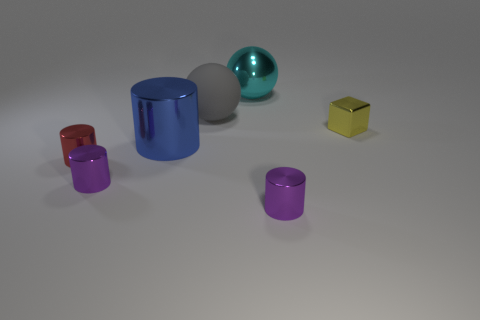Add 1 big gray objects. How many objects exist? 8 Subtract all spheres. How many objects are left? 5 Subtract all big gray rubber things. Subtract all small red shiny cylinders. How many objects are left? 5 Add 3 big rubber objects. How many big rubber objects are left? 4 Add 2 blocks. How many blocks exist? 3 Subtract 0 green balls. How many objects are left? 7 